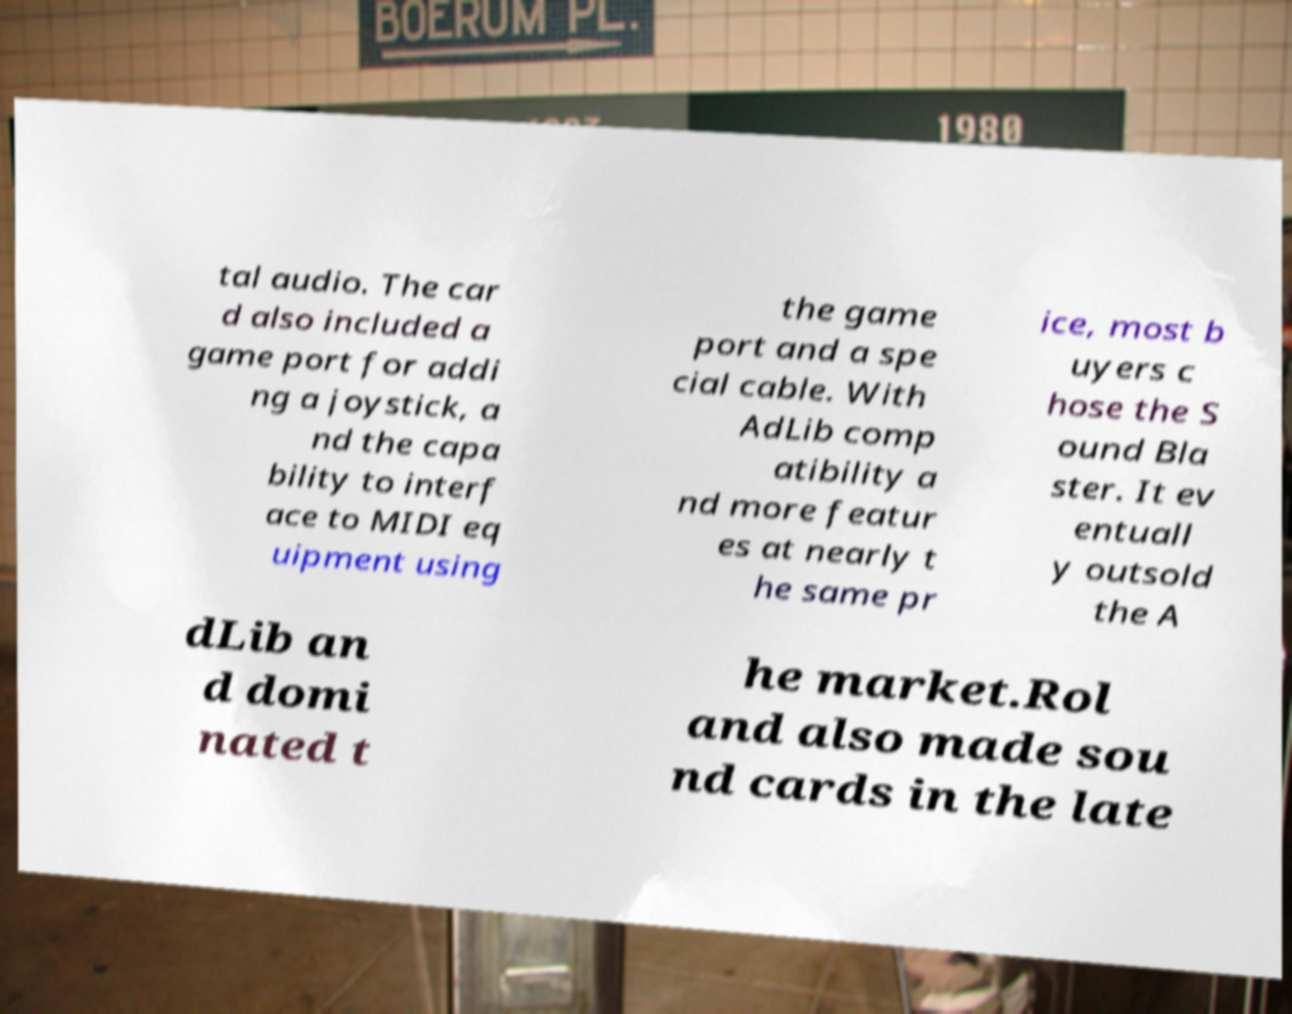Can you read and provide the text displayed in the image?This photo seems to have some interesting text. Can you extract and type it out for me? tal audio. The car d also included a game port for addi ng a joystick, a nd the capa bility to interf ace to MIDI eq uipment using the game port and a spe cial cable. With AdLib comp atibility a nd more featur es at nearly t he same pr ice, most b uyers c hose the S ound Bla ster. It ev entuall y outsold the A dLib an d domi nated t he market.Rol and also made sou nd cards in the late 